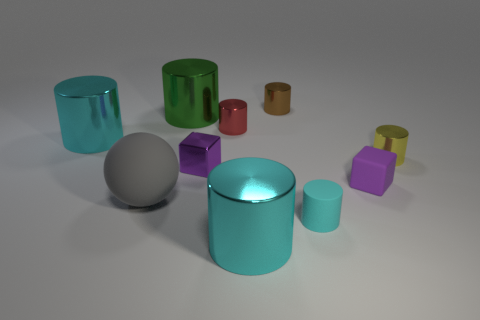Does the small red thing have the same material as the gray sphere?
Your response must be concise. No. How many other things are the same shape as the cyan matte thing?
Offer a very short reply. 6. How big is the cyan thing that is both on the right side of the small red shiny thing and on the left side of the small cyan cylinder?
Offer a very short reply. Large. There is a purple object that is made of the same material as the yellow thing; what shape is it?
Offer a very short reply. Cube. There is a cyan metallic cylinder behind the yellow metallic cylinder; is there a tiny purple metal thing left of it?
Keep it short and to the point. No. What material is the small brown object that is the same shape as the small yellow thing?
Offer a terse response. Metal. There is a small brown cylinder to the left of the small cyan thing; how many green cylinders are on the right side of it?
Your answer should be compact. 0. Is there any other thing of the same color as the ball?
Make the answer very short. No. What number of objects are tiny purple metallic objects or small objects behind the large green cylinder?
Offer a very short reply. 2. What is the big cylinder behind the big cyan thing behind the cyan metal cylinder right of the gray matte ball made of?
Offer a terse response. Metal. 